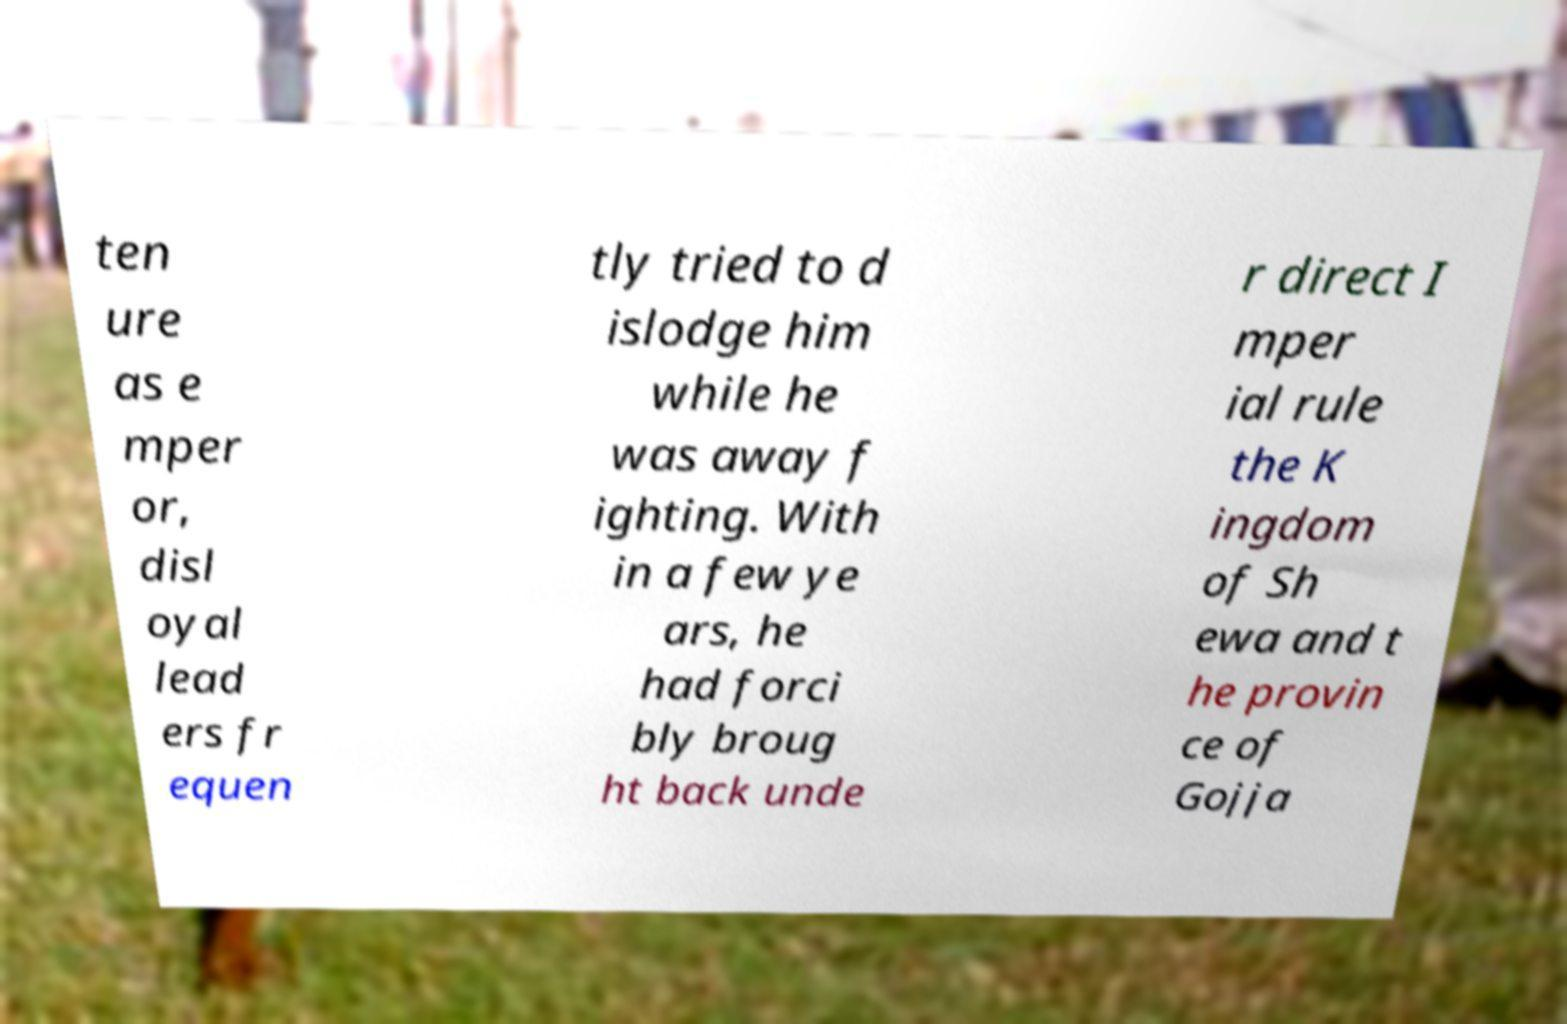Please identify and transcribe the text found in this image. ten ure as e mper or, disl oyal lead ers fr equen tly tried to d islodge him while he was away f ighting. With in a few ye ars, he had forci bly broug ht back unde r direct I mper ial rule the K ingdom of Sh ewa and t he provin ce of Gojja 